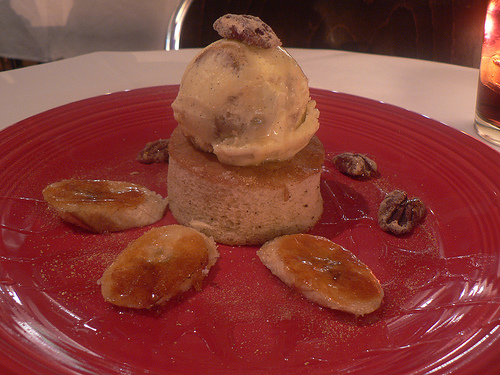<image>
Can you confirm if the pecan is behind the icecream? Yes. From this viewpoint, the pecan is positioned behind the icecream, with the icecream partially or fully occluding the pecan. 